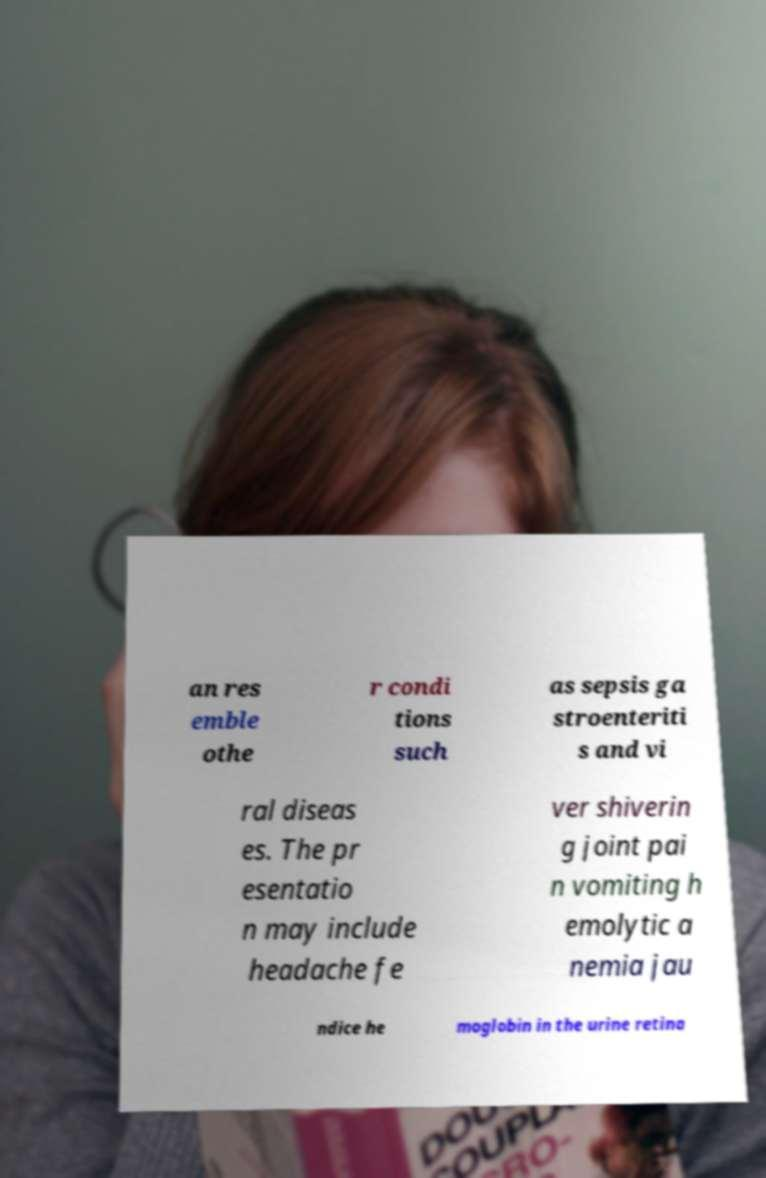There's text embedded in this image that I need extracted. Can you transcribe it verbatim? an res emble othe r condi tions such as sepsis ga stroenteriti s and vi ral diseas es. The pr esentatio n may include headache fe ver shiverin g joint pai n vomiting h emolytic a nemia jau ndice he moglobin in the urine retina 